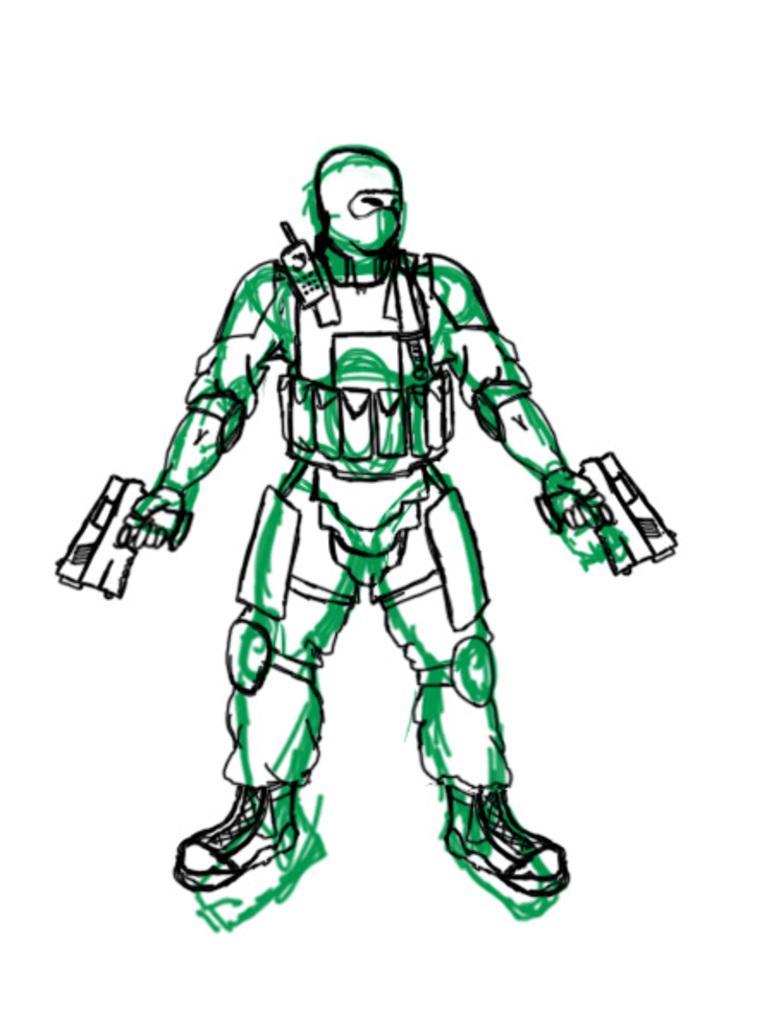Could you give a brief overview of what you see in this image? In this image I can see a drawing and I can see colour of the drawing is green, black and white. I can also see white colour in the background. 